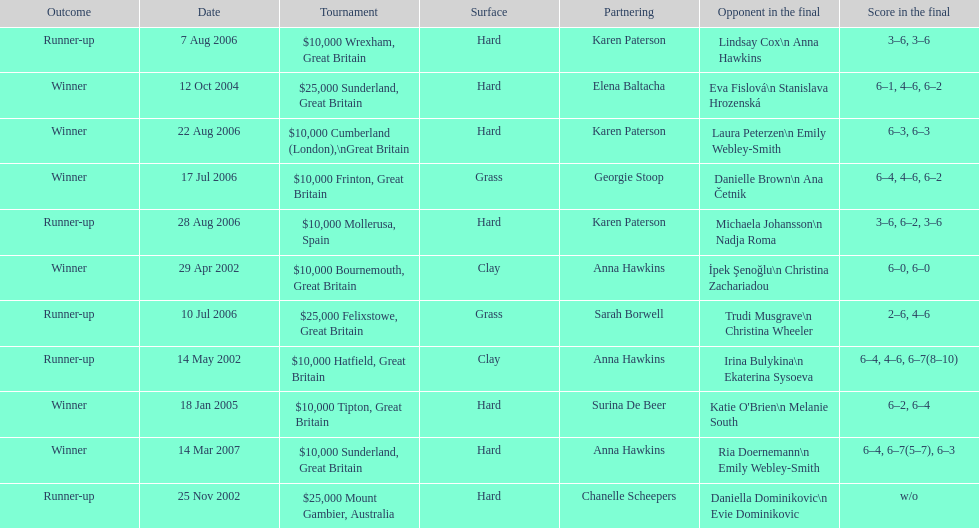What is the number of prize money for the 14 may 2002 tournament? $10,000. 